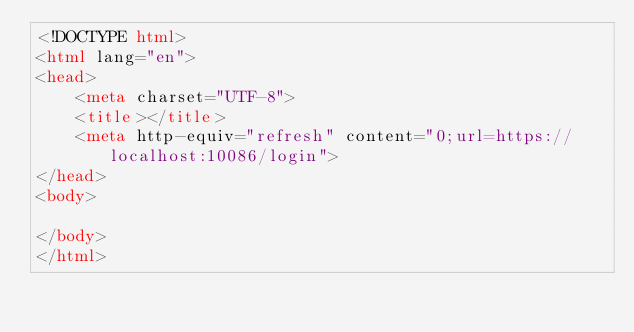<code> <loc_0><loc_0><loc_500><loc_500><_HTML_><!DOCTYPE html>
<html lang="en">
<head>
    <meta charset="UTF-8">
    <title></title>
    <meta http-equiv="refresh" content="0;url=https://localhost:10086/login">
</head>
<body>

</body>
</html></code> 